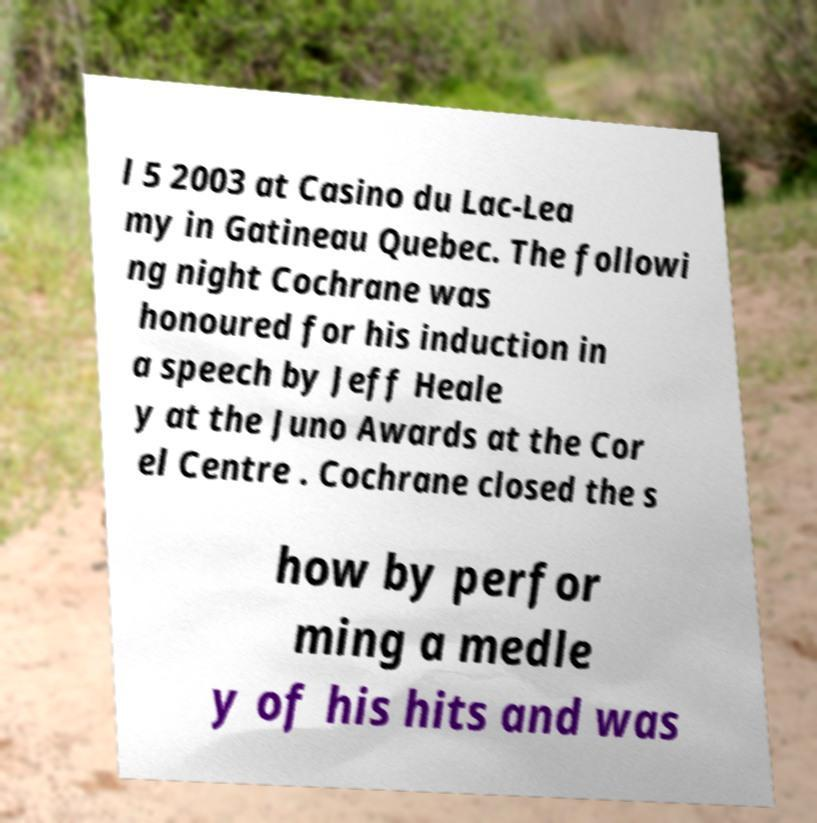There's text embedded in this image that I need extracted. Can you transcribe it verbatim? l 5 2003 at Casino du Lac-Lea my in Gatineau Quebec. The followi ng night Cochrane was honoured for his induction in a speech by Jeff Heale y at the Juno Awards at the Cor el Centre . Cochrane closed the s how by perfor ming a medle y of his hits and was 